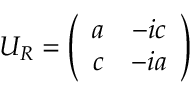<formula> <loc_0><loc_0><loc_500><loc_500>U _ { R } = \left ( \begin{array} { c c } { a } & { - i c } \\ { c } & { - i a } \end{array} \right )</formula> 